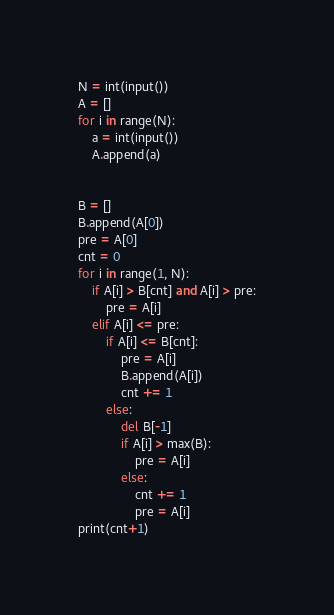<code> <loc_0><loc_0><loc_500><loc_500><_Python_>N = int(input())
A = []
for i in range(N):
    a = int(input())
    A.append(a)
    
    
B = []
B.append(A[0])
pre = A[0]
cnt = 0
for i in range(1, N):
    if A[i] > B[cnt] and A[i] > pre:
        pre = A[i]
    elif A[i] <= pre:
        if A[i] <= B[cnt]:
            pre = A[i]
            B.append(A[i])
            cnt += 1
        else:
            del B[-1]
            if A[i] > max(B):
                pre = A[i]
            else:
                cnt += 1
                pre = A[i]
print(cnt+1)</code> 